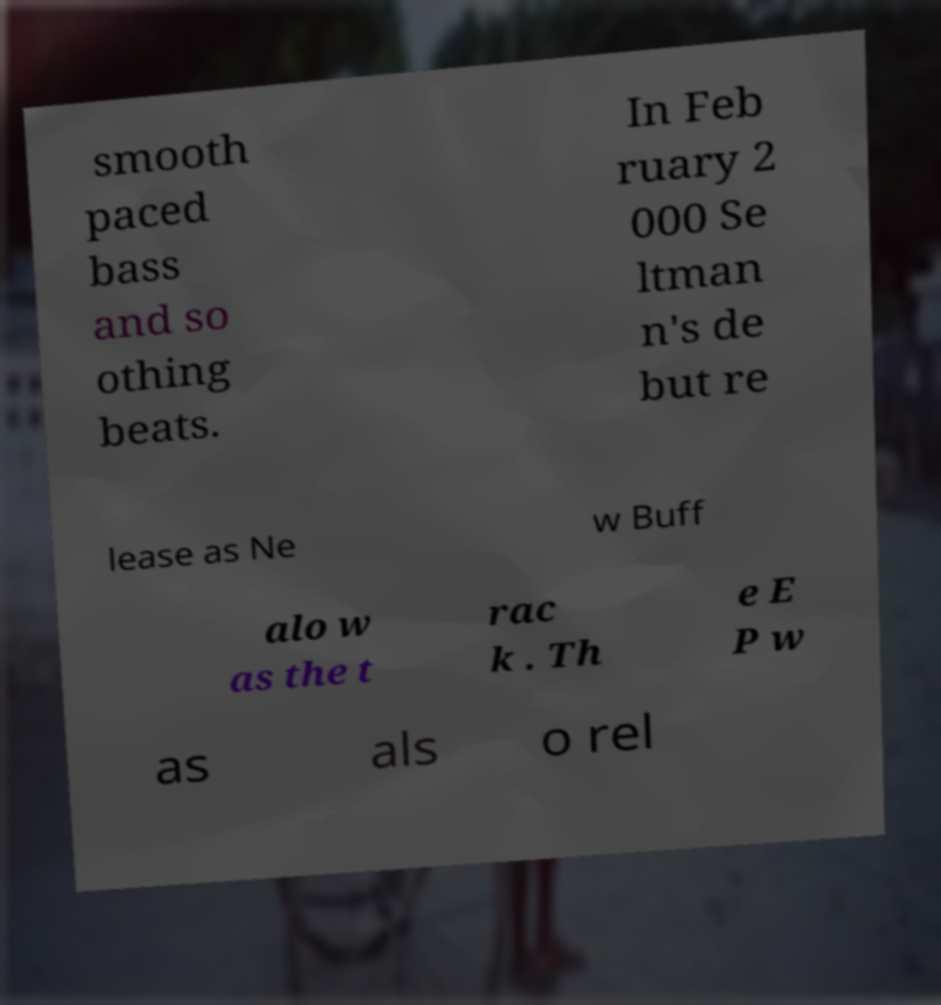Please identify and transcribe the text found in this image. smooth paced bass and so othing beats. In Feb ruary 2 000 Se ltman n's de but re lease as Ne w Buff alo w as the t rac k . Th e E P w as als o rel 